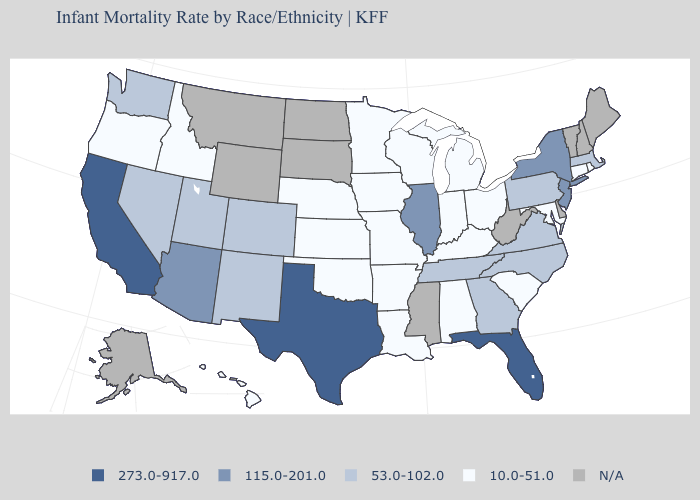Name the states that have a value in the range 10.0-51.0?
Keep it brief. Alabama, Arkansas, Connecticut, Hawaii, Idaho, Indiana, Iowa, Kansas, Kentucky, Louisiana, Maryland, Michigan, Minnesota, Missouri, Nebraska, Ohio, Oklahoma, Oregon, Rhode Island, South Carolina, Wisconsin. Does Kansas have the lowest value in the MidWest?
Answer briefly. Yes. Name the states that have a value in the range 53.0-102.0?
Write a very short answer. Colorado, Georgia, Massachusetts, Nevada, New Mexico, North Carolina, Pennsylvania, Tennessee, Utah, Virginia, Washington. Name the states that have a value in the range 53.0-102.0?
Short answer required. Colorado, Georgia, Massachusetts, Nevada, New Mexico, North Carolina, Pennsylvania, Tennessee, Utah, Virginia, Washington. Does Texas have the highest value in the USA?
Answer briefly. Yes. Which states hav the highest value in the MidWest?
Short answer required. Illinois. What is the value of North Dakota?
Answer briefly. N/A. Name the states that have a value in the range 10.0-51.0?
Concise answer only. Alabama, Arkansas, Connecticut, Hawaii, Idaho, Indiana, Iowa, Kansas, Kentucky, Louisiana, Maryland, Michigan, Minnesota, Missouri, Nebraska, Ohio, Oklahoma, Oregon, Rhode Island, South Carolina, Wisconsin. Name the states that have a value in the range 115.0-201.0?
Give a very brief answer. Arizona, Illinois, New Jersey, New York. What is the highest value in the South ?
Quick response, please. 273.0-917.0. Name the states that have a value in the range 53.0-102.0?
Concise answer only. Colorado, Georgia, Massachusetts, Nevada, New Mexico, North Carolina, Pennsylvania, Tennessee, Utah, Virginia, Washington. What is the highest value in the USA?
Give a very brief answer. 273.0-917.0. What is the highest value in the MidWest ?
Short answer required. 115.0-201.0. How many symbols are there in the legend?
Quick response, please. 5. Is the legend a continuous bar?
Keep it brief. No. 